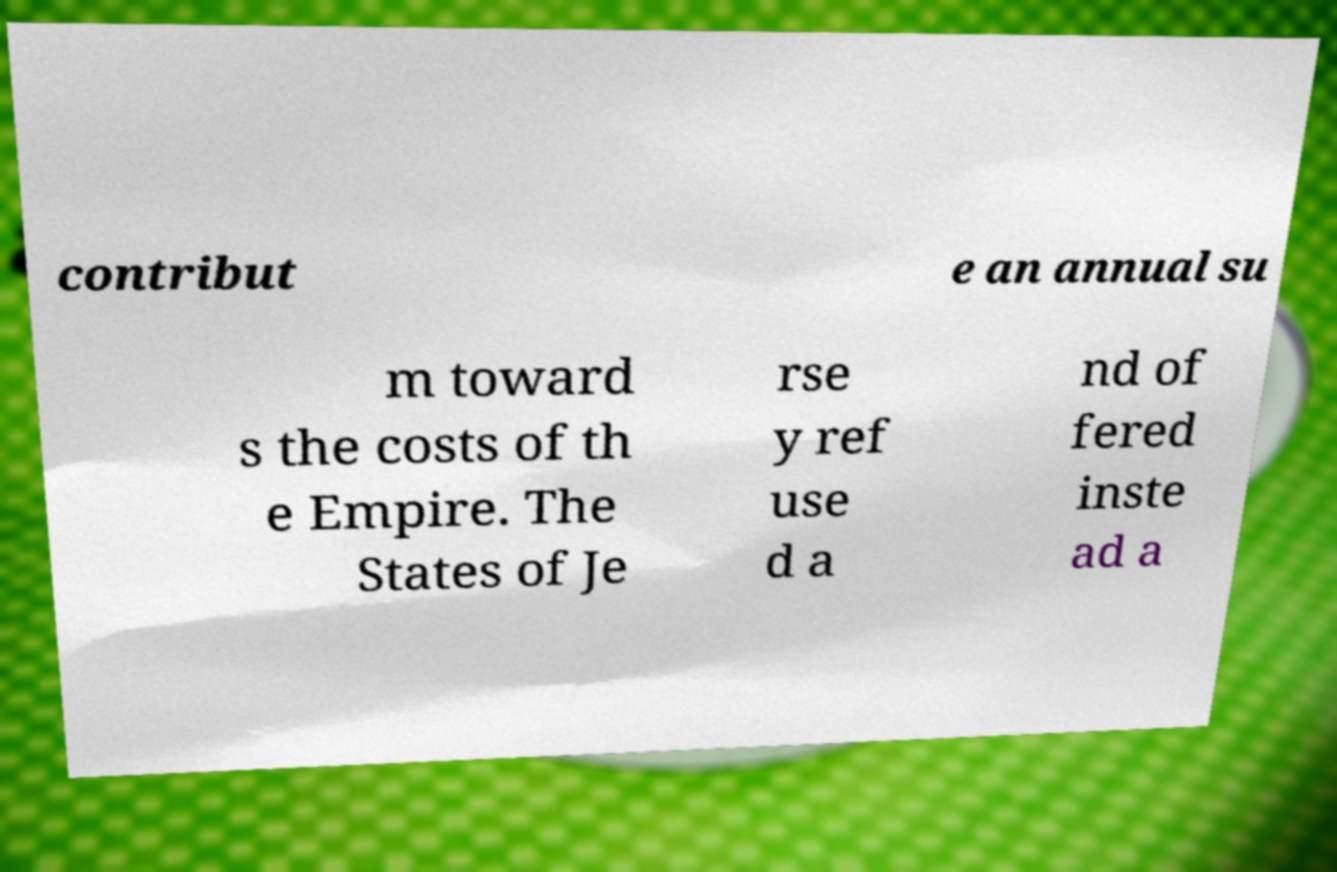What messages or text are displayed in this image? I need them in a readable, typed format. contribut e an annual su m toward s the costs of th e Empire. The States of Je rse y ref use d a nd of fered inste ad a 